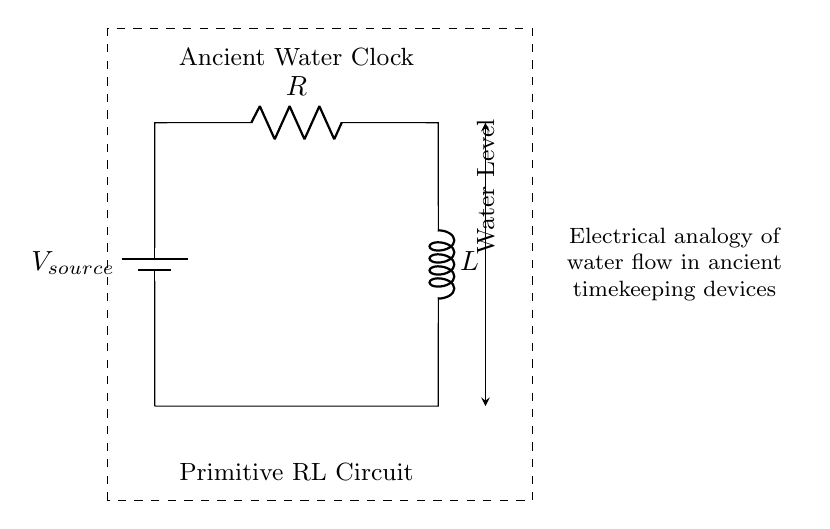What type of components are present in this circuit? The circuit contains a resistor and an inductor, which are the primary components depicted above the battery in the diagram.
Answer: Resistor and inductor What is the function of the inductor in this circuit? The inductor stores energy in a magnetic field when current flows through it, providing timing functions in the circuit, which parallels the timekeeping properties of ancient water clocks.
Answer: Stores energy What does the dashed rectangle represent in this diagram? The dashed rectangle outlines the entire circuit, indicating the limits of the primitive RL circuit that emulates ancient electrical timing devices, such as water clocks.
Answer: The circuit boundaries What does the arrow pointing to the water level indicate? The arrow symbolizes the flow of current and water levels in the analogy of the circuit, suggesting how the inductor and resistor work together to mimic water movement in ancient timekeeping devices.
Answer: Current and water analogy How does the presence of a resistor affect current? A resistor provides resistance to the flow of current, causing a voltage drop and influencing the rate at which the inductor stores energy, thus affecting the dynamic response of the RL circuit over time.
Answer: Reduces current What concept does the RL circuit illustrate in relation to water clocks? The circuit serves as an electrical analogy to the flow of water in ancient water clocks, where the inductor and resistor simulate the timing mechanism that relies on water levels.
Answer: Electrical analogy 